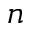<formula> <loc_0><loc_0><loc_500><loc_500>n</formula> 